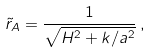<formula> <loc_0><loc_0><loc_500><loc_500>\tilde { r } _ { A } = \frac { 1 } { \sqrt { H ^ { 2 } + k / a ^ { 2 } } } \, ,</formula> 